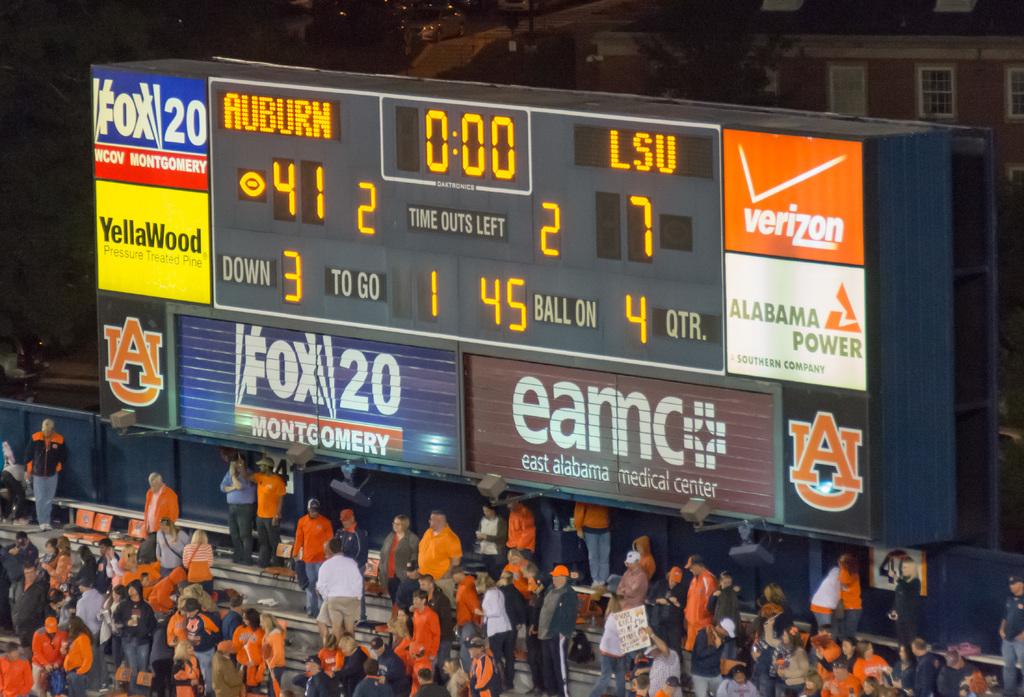How many points does auburn have?
Provide a short and direct response. 41. What is the t.v. logo on the sign?
Ensure brevity in your answer.  Fox 20. 